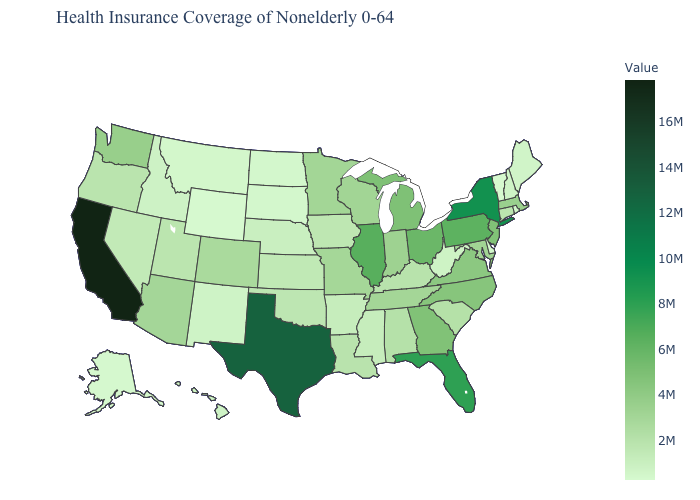Among the states that border Texas , which have the lowest value?
Write a very short answer. New Mexico. Does Iowa have a higher value than Texas?
Quick response, please. No. Which states hav the highest value in the Northeast?
Be succinct. New York. Among the states that border Arizona , which have the lowest value?
Be succinct. New Mexico. Which states have the highest value in the USA?
Concise answer only. California. 